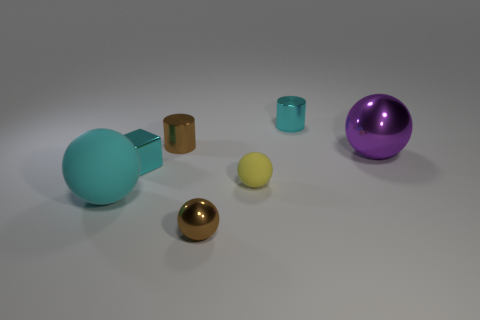Subtract all small yellow matte balls. How many balls are left? 3 Subtract all purple balls. How many balls are left? 3 Add 1 yellow cylinders. How many objects exist? 8 Subtract all brown spheres. Subtract all purple cylinders. How many spheres are left? 3 Subtract all blocks. How many objects are left? 6 Add 7 brown metallic cylinders. How many brown metallic cylinders exist? 8 Subtract 0 blue balls. How many objects are left? 7 Subtract all big rubber objects. Subtract all brown cylinders. How many objects are left? 5 Add 6 large purple metallic spheres. How many large purple metallic spheres are left? 7 